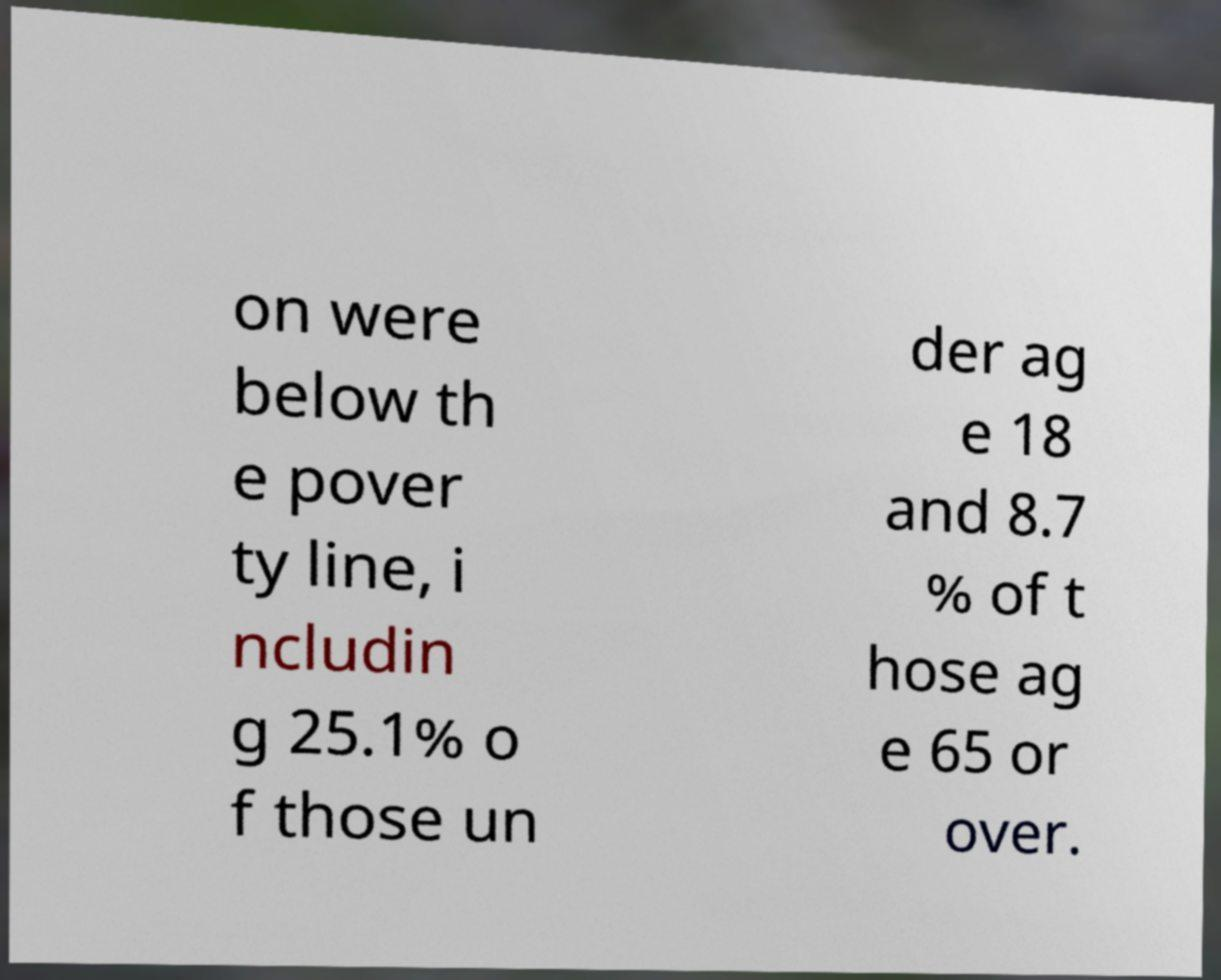For documentation purposes, I need the text within this image transcribed. Could you provide that? on were below th e pover ty line, i ncludin g 25.1% o f those un der ag e 18 and 8.7 % of t hose ag e 65 or over. 